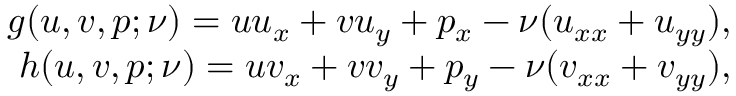<formula> <loc_0><loc_0><loc_500><loc_500>\begin{array} { r } { g ( u , v , p ; \nu ) = u u _ { x } + v u _ { y } + p _ { x } - \nu ( u _ { x x } + u _ { y y } ) , } \\ { h ( u , v , p ; \nu ) = u v _ { x } + v v _ { y } + p _ { y } - \nu ( v _ { x x } + v _ { y y } ) , } \end{array}</formula> 